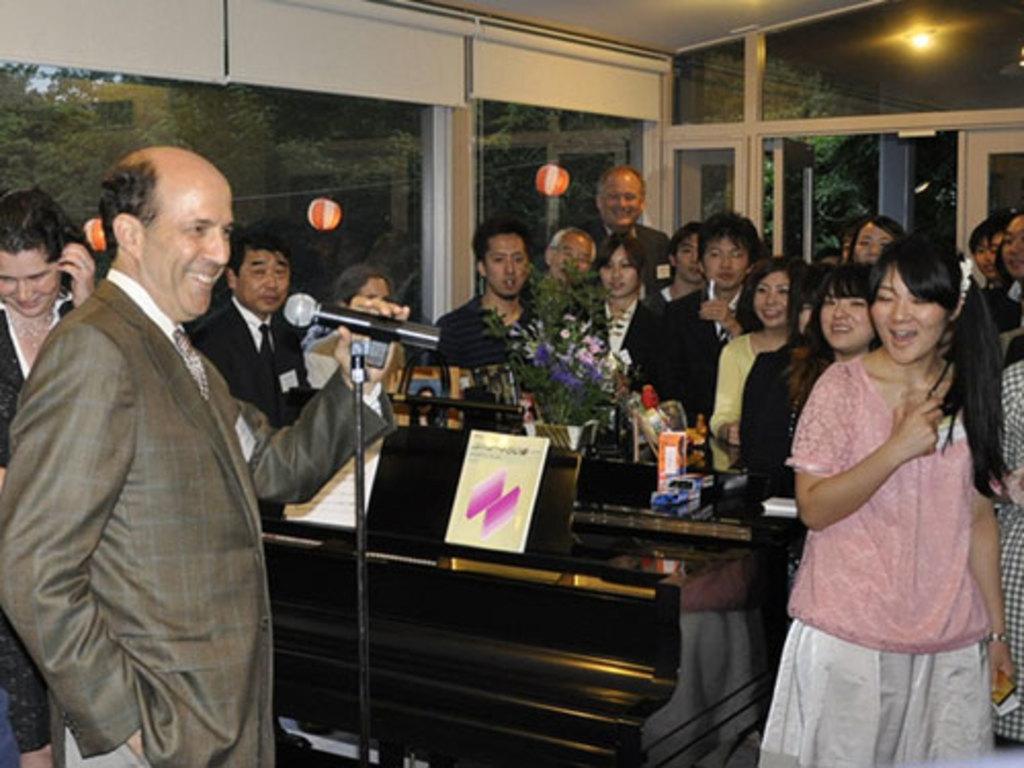How would you summarize this image in a sentence or two? There are groups of people standing. This is the mike, which is attached to the mike stand. I think this is a piano. I can see the books on the music stand. This looks like a flower vase and few other things are placed on the table. These are the glass doors. I can see the trees through the glass doors. This looks like a door. 